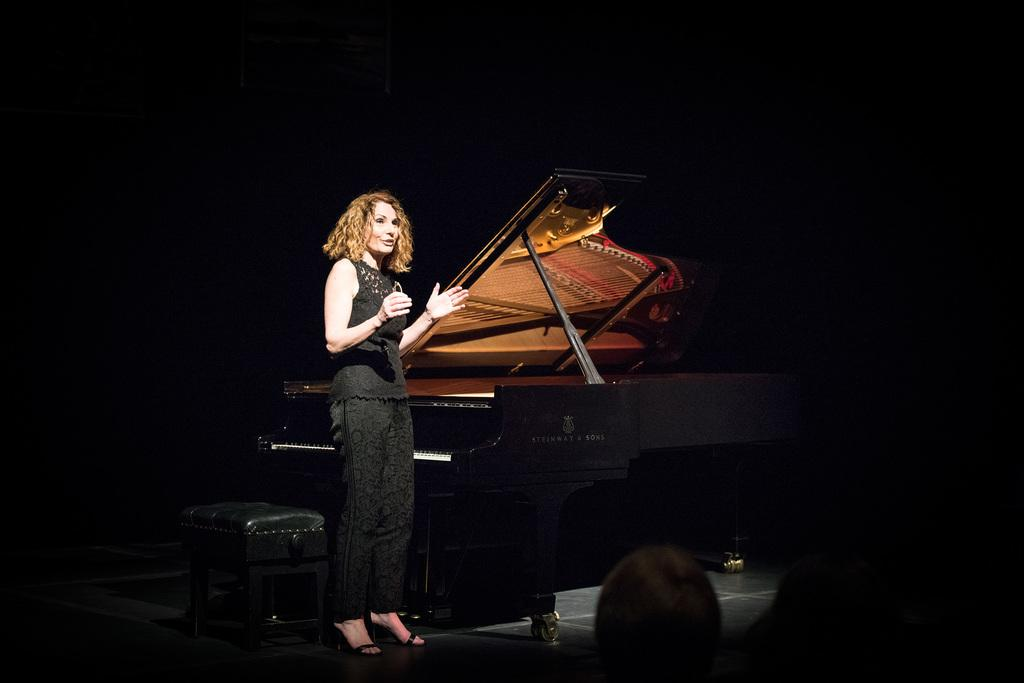Who is present in the image? There is a woman in the image. What is the woman doing in the image? The woman is standing and speaking. What musical instrument is in the image? There is a violin in the image. What piece of furniture is in the image? There is a stool in the image. What type of wool is being used to make the banana in the image? There is no wool or banana present in the image. 